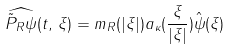<formula> <loc_0><loc_0><loc_500><loc_500>\widehat { \tilde { P } _ { R } \psi } ( t , \, \xi ) = m _ { R } ( | \xi | ) a _ { \kappa } ( \frac { \xi } { | \xi | } ) \hat { \psi } ( \xi )</formula> 